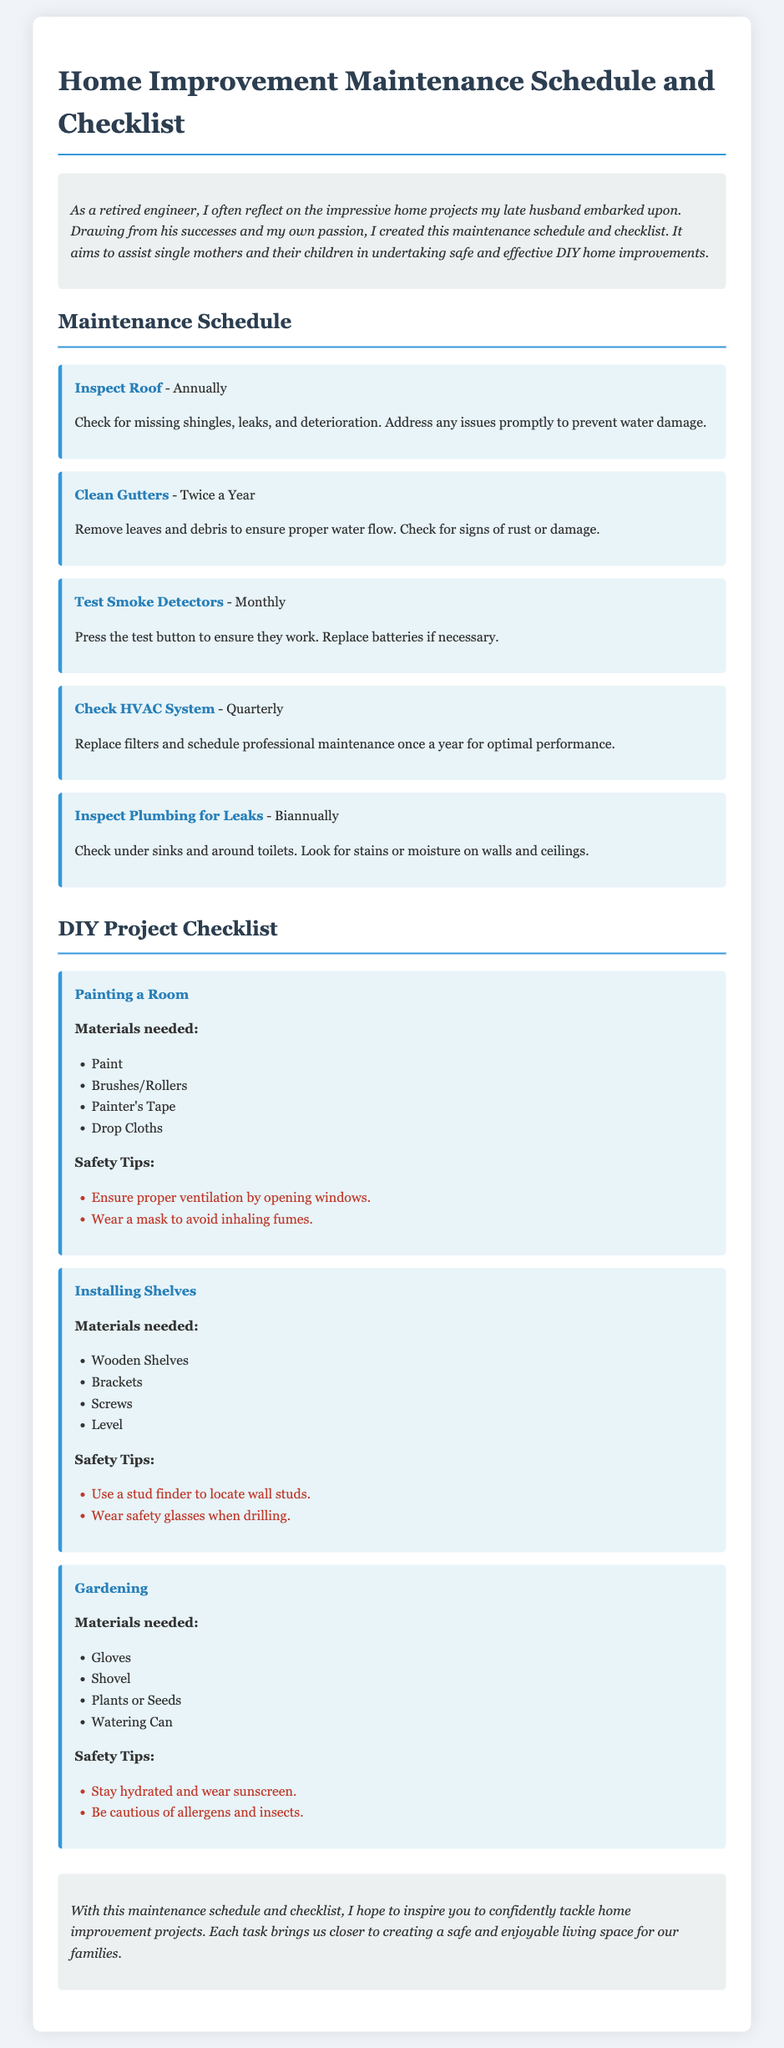what is the frequency of inspecting the roof? The document states that inspecting the roof is to be done annually.
Answer: Annually how often should smoke detectors be tested? According to the document, smoke detectors should be tested monthly.
Answer: Monthly what is a safety tip for painting a room? The document lists wearing a mask to avoid inhaling fumes as a safety tip for painting a room.
Answer: Wear a mask how many times a year should gutters be cleaned? The document indicates that gutters should be cleaned twice a year.
Answer: Twice a Year what material is needed for installing shelves? The document lists wooden shelves as one of the materials needed for installing shelves.
Answer: Wooden Shelves what is the purpose of using a stud finder? The document mentions using a stud finder to locate wall studs during the installation of shelves.
Answer: To locate wall studs how does the introduction frame the purpose of the document? The introduction shares that the document aims to assist single mothers and their children in DIY home improvements.
Answer: Assist single mothers and their children what safety measure should be taken when gardening? The document recommends staying hydrated and wearing sunscreen as a safety measure when gardening.
Answer: Stay hydrated how many maintenance tasks are listed in the document? The document lists five maintenance tasks in total.
Answer: Five 